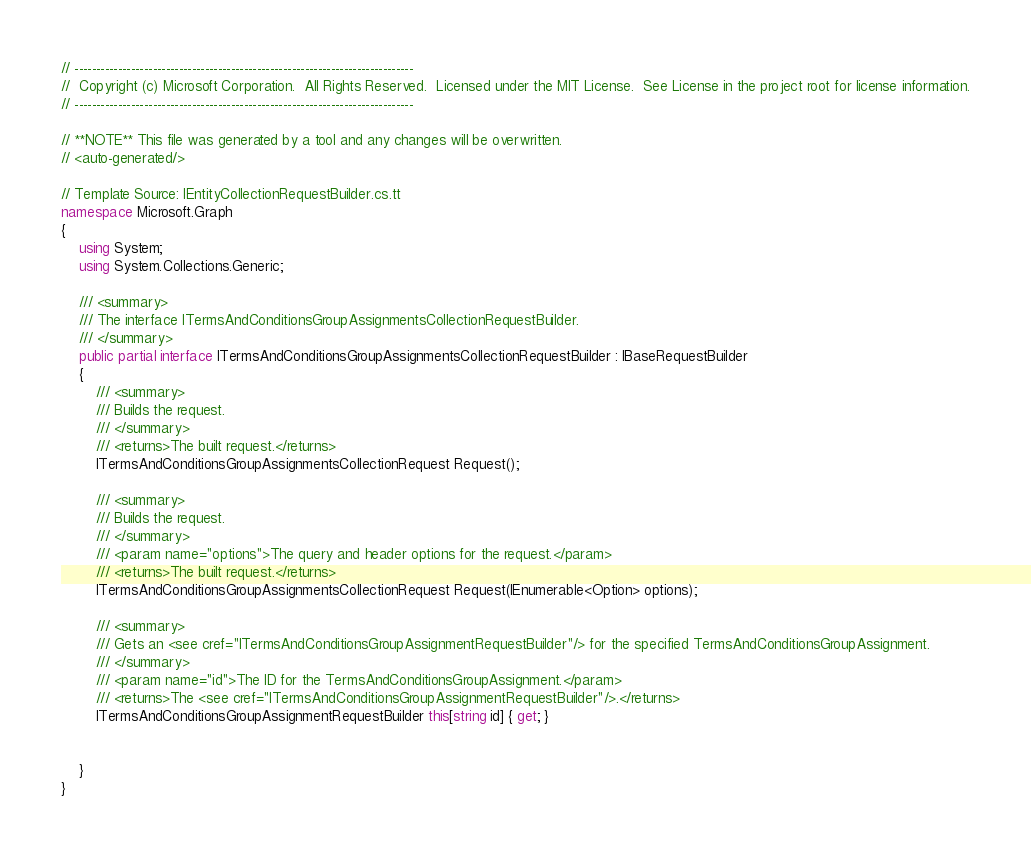Convert code to text. <code><loc_0><loc_0><loc_500><loc_500><_C#_>// ------------------------------------------------------------------------------
//  Copyright (c) Microsoft Corporation.  All Rights Reserved.  Licensed under the MIT License.  See License in the project root for license information.
// ------------------------------------------------------------------------------

// **NOTE** This file was generated by a tool and any changes will be overwritten.
// <auto-generated/>

// Template Source: IEntityCollectionRequestBuilder.cs.tt
namespace Microsoft.Graph
{
    using System;
    using System.Collections.Generic;

    /// <summary>
    /// The interface ITermsAndConditionsGroupAssignmentsCollectionRequestBuilder.
    /// </summary>
    public partial interface ITermsAndConditionsGroupAssignmentsCollectionRequestBuilder : IBaseRequestBuilder
    {
        /// <summary>
        /// Builds the request.
        /// </summary>
        /// <returns>The built request.</returns>
        ITermsAndConditionsGroupAssignmentsCollectionRequest Request();

        /// <summary>
        /// Builds the request.
        /// </summary>
        /// <param name="options">The query and header options for the request.</param>
        /// <returns>The built request.</returns>
        ITermsAndConditionsGroupAssignmentsCollectionRequest Request(IEnumerable<Option> options);

        /// <summary>
        /// Gets an <see cref="ITermsAndConditionsGroupAssignmentRequestBuilder"/> for the specified TermsAndConditionsGroupAssignment.
        /// </summary>
        /// <param name="id">The ID for the TermsAndConditionsGroupAssignment.</param>
        /// <returns>The <see cref="ITermsAndConditionsGroupAssignmentRequestBuilder"/>.</returns>
        ITermsAndConditionsGroupAssignmentRequestBuilder this[string id] { get; }

        
    }
}
</code> 